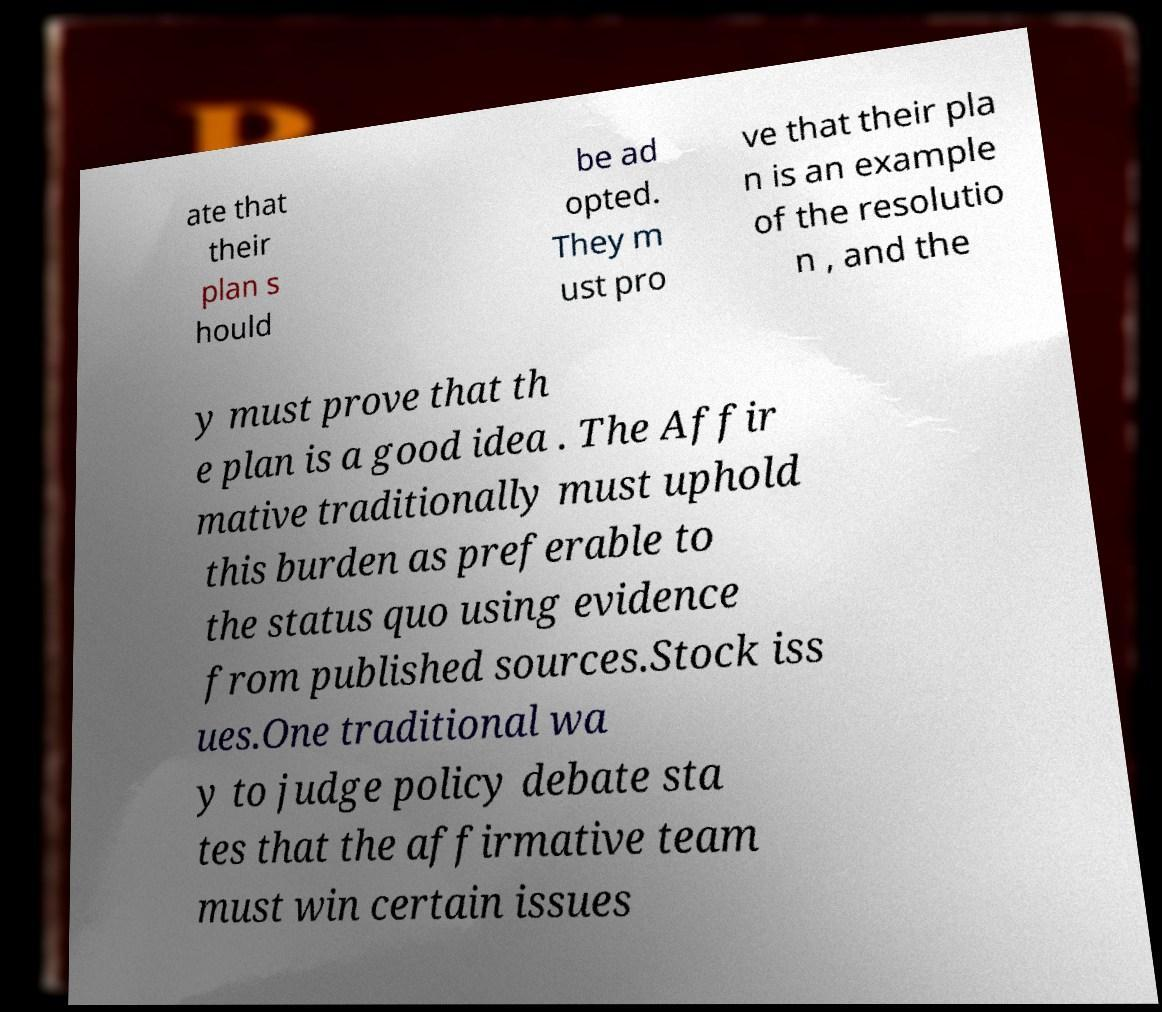There's text embedded in this image that I need extracted. Can you transcribe it verbatim? ate that their plan s hould be ad opted. They m ust pro ve that their pla n is an example of the resolutio n , and the y must prove that th e plan is a good idea . The Affir mative traditionally must uphold this burden as preferable to the status quo using evidence from published sources.Stock iss ues.One traditional wa y to judge policy debate sta tes that the affirmative team must win certain issues 